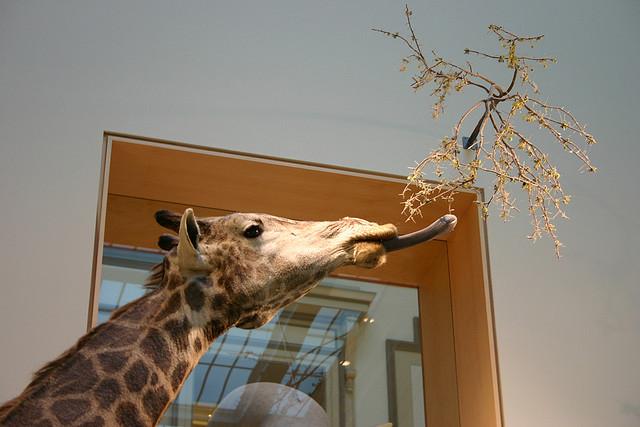Is that a mirror or a window behind the giraffe?
Concise answer only. Window. How many giraffes are there?
Give a very brief answer. 1. What is the animal trying to eat?
Be succinct. Branch. 